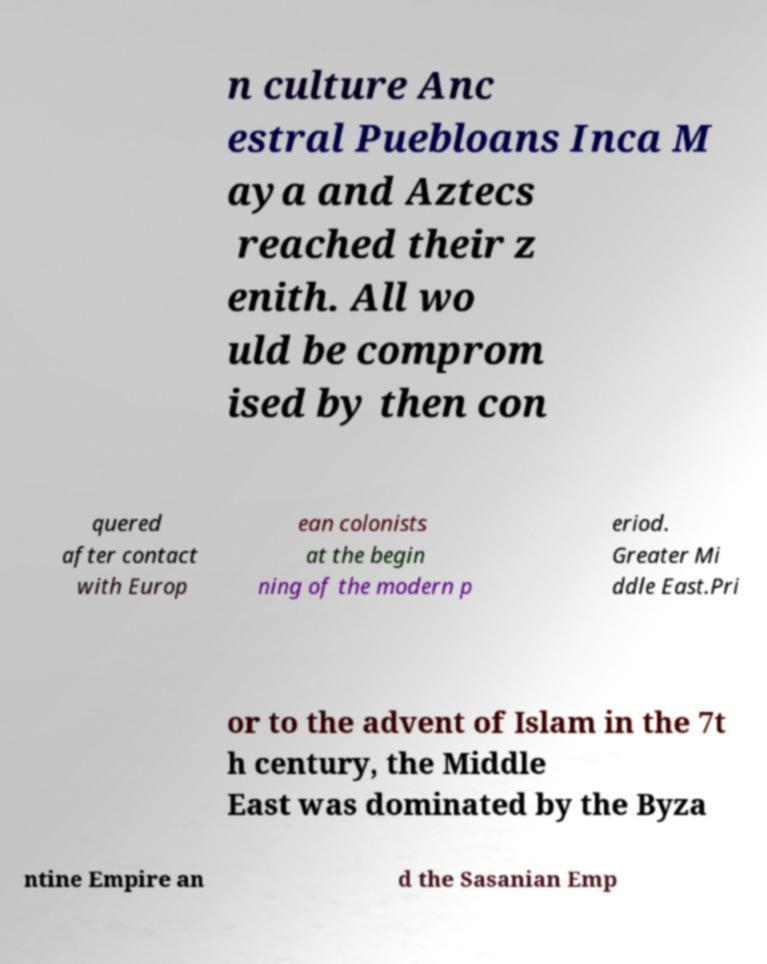Could you extract and type out the text from this image? n culture Anc estral Puebloans Inca M aya and Aztecs reached their z enith. All wo uld be comprom ised by then con quered after contact with Europ ean colonists at the begin ning of the modern p eriod. Greater Mi ddle East.Pri or to the advent of Islam in the 7t h century, the Middle East was dominated by the Byza ntine Empire an d the Sasanian Emp 